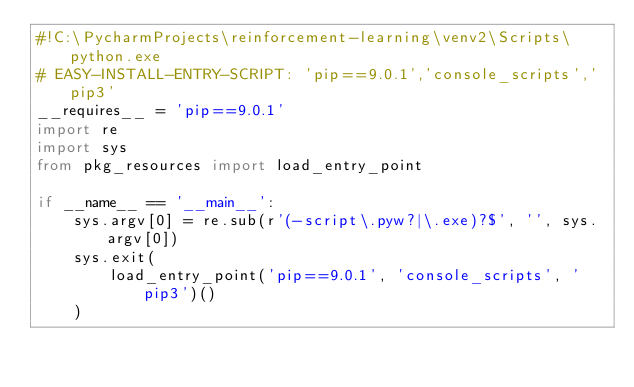<code> <loc_0><loc_0><loc_500><loc_500><_Python_>#!C:\PycharmProjects\reinforcement-learning\venv2\Scripts\python.exe
# EASY-INSTALL-ENTRY-SCRIPT: 'pip==9.0.1','console_scripts','pip3'
__requires__ = 'pip==9.0.1'
import re
import sys
from pkg_resources import load_entry_point

if __name__ == '__main__':
    sys.argv[0] = re.sub(r'(-script\.pyw?|\.exe)?$', '', sys.argv[0])
    sys.exit(
        load_entry_point('pip==9.0.1', 'console_scripts', 'pip3')()
    )
</code> 